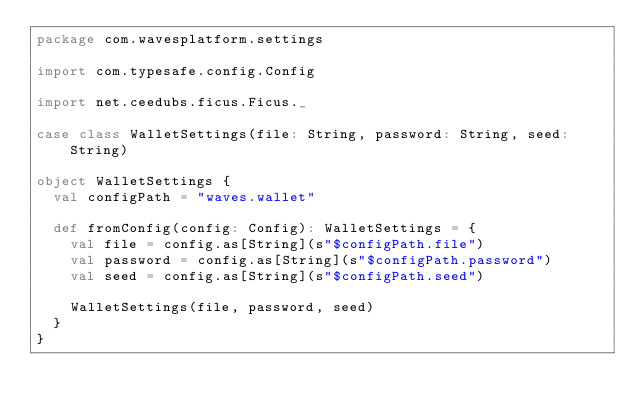Convert code to text. <code><loc_0><loc_0><loc_500><loc_500><_Scala_>package com.wavesplatform.settings

import com.typesafe.config.Config

import net.ceedubs.ficus.Ficus._

case class WalletSettings(file: String, password: String, seed: String)

object WalletSettings {
  val configPath = "waves.wallet"

  def fromConfig(config: Config): WalletSettings = {
    val file = config.as[String](s"$configPath.file")
    val password = config.as[String](s"$configPath.password")
    val seed = config.as[String](s"$configPath.seed")

    WalletSettings(file, password, seed)
  }
}</code> 